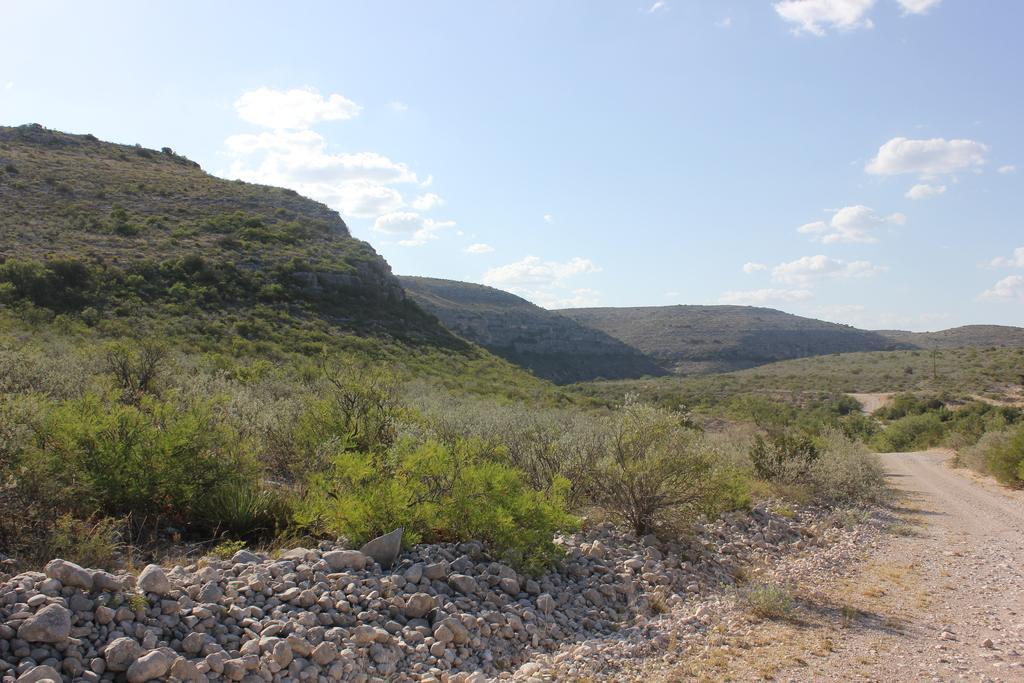Could you give a brief overview of what you see in this image? In this picture I can see there is a road which is made of soil and there are stones, rocks, plants and trees, in the backdrop there are mountains and they are covered with trees. 